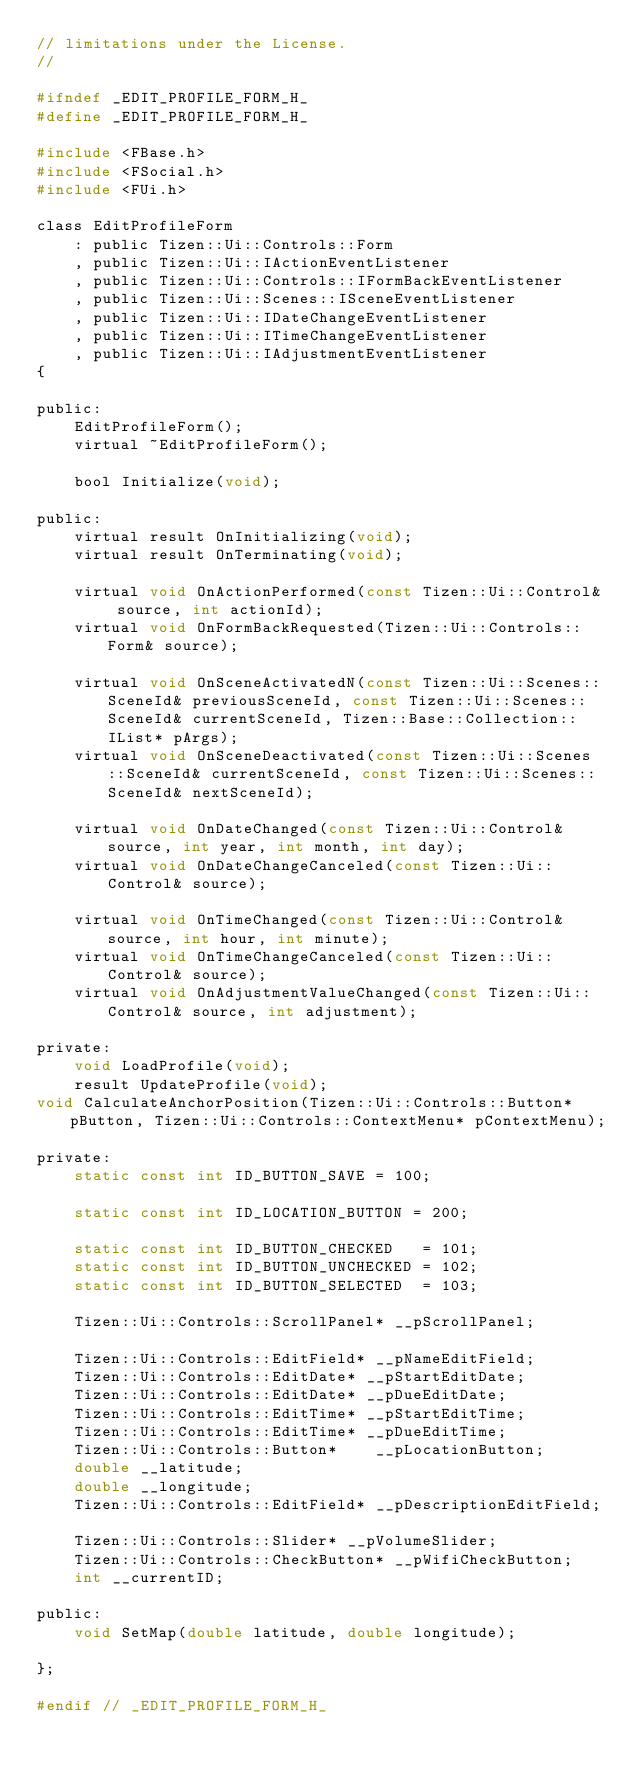<code> <loc_0><loc_0><loc_500><loc_500><_C_>// limitations under the License.
//

#ifndef _EDIT_PROFILE_FORM_H_
#define _EDIT_PROFILE_FORM_H_

#include <FBase.h>
#include <FSocial.h>
#include <FUi.h>

class EditProfileForm
	: public Tizen::Ui::Controls::Form
	, public Tizen::Ui::IActionEventListener
	, public Tizen::Ui::Controls::IFormBackEventListener
	, public Tizen::Ui::Scenes::ISceneEventListener
	, public Tizen::Ui::IDateChangeEventListener
	, public Tizen::Ui::ITimeChangeEventListener
    , public Tizen::Ui::IAdjustmentEventListener
{

public:
	EditProfileForm();
	virtual ~EditProfileForm();

	bool Initialize(void);

public:
	virtual result OnInitializing(void);
	virtual result OnTerminating(void);

	virtual void OnActionPerformed(const Tizen::Ui::Control& source, int actionId);
	virtual void OnFormBackRequested(Tizen::Ui::Controls::Form& source);

	virtual void OnSceneActivatedN(const Tizen::Ui::Scenes::SceneId& previousSceneId, const Tizen::Ui::Scenes::SceneId& currentSceneId, Tizen::Base::Collection::IList* pArgs);
	virtual void OnSceneDeactivated(const Tizen::Ui::Scenes::SceneId& currentSceneId, const Tizen::Ui::Scenes::SceneId& nextSceneId);

	virtual void OnDateChanged(const Tizen::Ui::Control& source, int year, int month, int day);
	virtual void OnDateChangeCanceled(const Tizen::Ui::Control& source);

	virtual void OnTimeChanged(const Tizen::Ui::Control& source, int hour, int minute);
	virtual void OnTimeChangeCanceled(const Tizen::Ui::Control& source);
    virtual void OnAdjustmentValueChanged(const Tizen::Ui::Control& source, int adjustment);

private:
	void LoadProfile(void);
	result UpdateProfile(void);
void CalculateAnchorPosition(Tizen::Ui::Controls::Button* pButton, Tizen::Ui::Controls::ContextMenu* pContextMenu);

private:
	static const int ID_BUTTON_SAVE = 100;

	static const int ID_LOCATION_BUTTON = 200;

	static const int ID_BUTTON_CHECKED   = 101;
    static const int ID_BUTTON_UNCHECKED = 102;
    static const int ID_BUTTON_SELECTED  = 103;

	Tizen::Ui::Controls::ScrollPanel* __pScrollPanel;
    
    Tizen::Ui::Controls::EditField* __pNameEditField;
    Tizen::Ui::Controls::EditDate* __pStartEditDate;
	Tizen::Ui::Controls::EditDate* __pDueEditDate;
	Tizen::Ui::Controls::EditTime* __pStartEditTime;
	Tizen::Ui::Controls::EditTime* __pDueEditTime;
	Tizen::Ui::Controls::Button*    __pLocationButton;
	double __latitude;
	double __longitude;
	Tizen::Ui::Controls::EditField* __pDescriptionEditField;
    
    Tizen::Ui::Controls::Slider* __pVolumeSlider;
    Tizen::Ui::Controls::CheckButton* __pWifiCheckButton;
    int __currentID;

public:
    void SetMap(double latitude, double longitude);

};

#endif // _EDIT_PROFILE_FORM_H_
</code> 